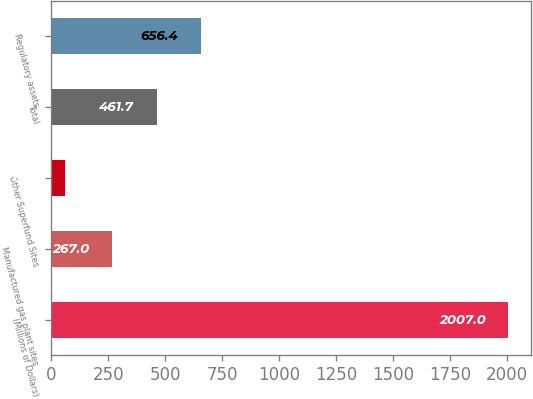Convert chart. <chart><loc_0><loc_0><loc_500><loc_500><bar_chart><fcel>(Millions of Dollars)<fcel>Manufactured gas plant sites<fcel>Other Superfund Sites<fcel>Total<fcel>Regulatory assets<nl><fcel>2007<fcel>267<fcel>60<fcel>461.7<fcel>656.4<nl></chart> 